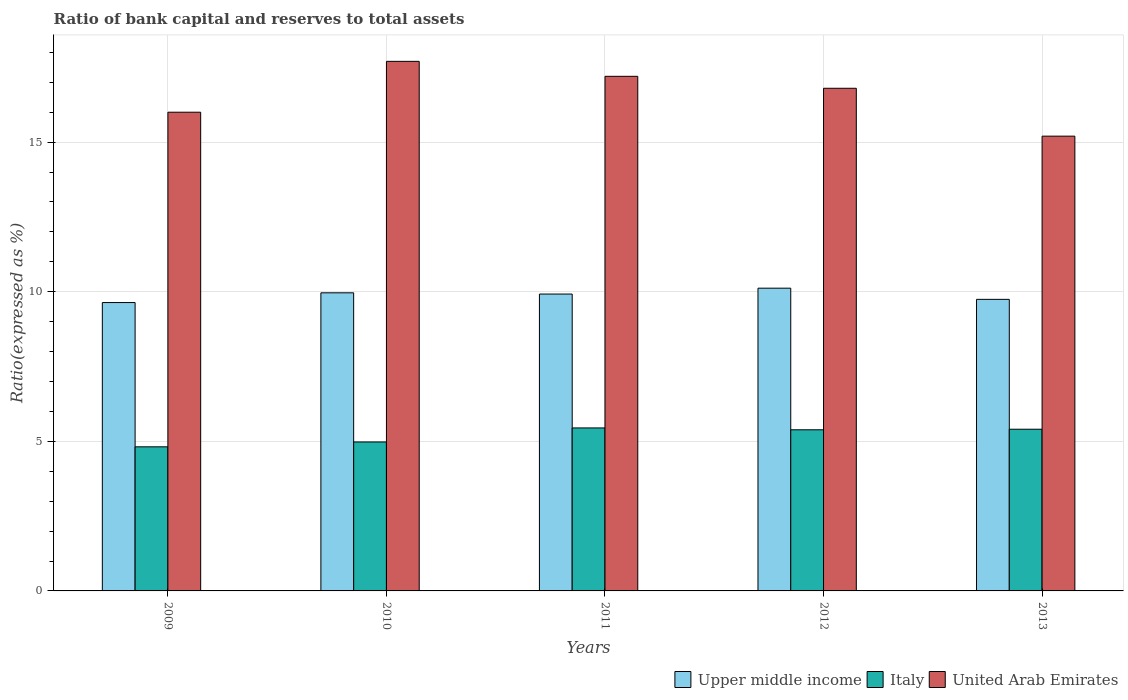How many different coloured bars are there?
Give a very brief answer. 3. How many bars are there on the 4th tick from the left?
Keep it short and to the point. 3. How many bars are there on the 4th tick from the right?
Your answer should be compact. 3. What is the ratio of bank capital and reserves to total assets in Italy in 2011?
Provide a succinct answer. 5.45. Across all years, what is the maximum ratio of bank capital and reserves to total assets in Italy?
Ensure brevity in your answer.  5.45. What is the total ratio of bank capital and reserves to total assets in Upper middle income in the graph?
Provide a succinct answer. 49.39. What is the difference between the ratio of bank capital and reserves to total assets in United Arab Emirates in 2009 and that in 2011?
Give a very brief answer. -1.2. What is the difference between the ratio of bank capital and reserves to total assets in United Arab Emirates in 2009 and the ratio of bank capital and reserves to total assets in Upper middle income in 2012?
Your answer should be very brief. 5.88. What is the average ratio of bank capital and reserves to total assets in United Arab Emirates per year?
Your response must be concise. 16.58. In the year 2011, what is the difference between the ratio of bank capital and reserves to total assets in Italy and ratio of bank capital and reserves to total assets in Upper middle income?
Keep it short and to the point. -4.47. What is the ratio of the ratio of bank capital and reserves to total assets in Upper middle income in 2009 to that in 2011?
Offer a very short reply. 0.97. Is the ratio of bank capital and reserves to total assets in United Arab Emirates in 2010 less than that in 2012?
Provide a short and direct response. No. What is the difference between the highest and the second highest ratio of bank capital and reserves to total assets in United Arab Emirates?
Give a very brief answer. 0.5. What is the difference between the highest and the lowest ratio of bank capital and reserves to total assets in Italy?
Make the answer very short. 0.63. In how many years, is the ratio of bank capital and reserves to total assets in United Arab Emirates greater than the average ratio of bank capital and reserves to total assets in United Arab Emirates taken over all years?
Ensure brevity in your answer.  3. Is the sum of the ratio of bank capital and reserves to total assets in United Arab Emirates in 2009 and 2010 greater than the maximum ratio of bank capital and reserves to total assets in Upper middle income across all years?
Make the answer very short. Yes. What does the 2nd bar from the left in 2012 represents?
Provide a short and direct response. Italy. What does the 1st bar from the right in 2011 represents?
Give a very brief answer. United Arab Emirates. Is it the case that in every year, the sum of the ratio of bank capital and reserves to total assets in Upper middle income and ratio of bank capital and reserves to total assets in Italy is greater than the ratio of bank capital and reserves to total assets in United Arab Emirates?
Keep it short and to the point. No. What is the difference between two consecutive major ticks on the Y-axis?
Your answer should be very brief. 5. Are the values on the major ticks of Y-axis written in scientific E-notation?
Give a very brief answer. No. Does the graph contain any zero values?
Give a very brief answer. No. Does the graph contain grids?
Your answer should be very brief. Yes. What is the title of the graph?
Provide a short and direct response. Ratio of bank capital and reserves to total assets. What is the label or title of the X-axis?
Keep it short and to the point. Years. What is the label or title of the Y-axis?
Make the answer very short. Ratio(expressed as %). What is the Ratio(expressed as %) of Upper middle income in 2009?
Your answer should be compact. 9.64. What is the Ratio(expressed as %) in Italy in 2009?
Ensure brevity in your answer.  4.82. What is the Ratio(expressed as %) in United Arab Emirates in 2009?
Make the answer very short. 16. What is the Ratio(expressed as %) of Upper middle income in 2010?
Make the answer very short. 9.96. What is the Ratio(expressed as %) of Italy in 2010?
Ensure brevity in your answer.  4.98. What is the Ratio(expressed as %) in United Arab Emirates in 2010?
Give a very brief answer. 17.7. What is the Ratio(expressed as %) of Upper middle income in 2011?
Keep it short and to the point. 9.92. What is the Ratio(expressed as %) in Italy in 2011?
Provide a succinct answer. 5.45. What is the Ratio(expressed as %) of Upper middle income in 2012?
Offer a very short reply. 10.12. What is the Ratio(expressed as %) in Italy in 2012?
Offer a terse response. 5.39. What is the Ratio(expressed as %) of United Arab Emirates in 2012?
Offer a terse response. 16.8. What is the Ratio(expressed as %) of Upper middle income in 2013?
Your answer should be very brief. 9.75. What is the Ratio(expressed as %) of Italy in 2013?
Your answer should be compact. 5.4. Across all years, what is the maximum Ratio(expressed as %) in Upper middle income?
Provide a succinct answer. 10.12. Across all years, what is the maximum Ratio(expressed as %) of Italy?
Provide a succinct answer. 5.45. Across all years, what is the minimum Ratio(expressed as %) of Upper middle income?
Your answer should be compact. 9.64. Across all years, what is the minimum Ratio(expressed as %) in Italy?
Make the answer very short. 4.82. Across all years, what is the minimum Ratio(expressed as %) of United Arab Emirates?
Your answer should be compact. 15.2. What is the total Ratio(expressed as %) of Upper middle income in the graph?
Your answer should be very brief. 49.39. What is the total Ratio(expressed as %) in Italy in the graph?
Provide a short and direct response. 26.03. What is the total Ratio(expressed as %) of United Arab Emirates in the graph?
Your response must be concise. 82.9. What is the difference between the Ratio(expressed as %) of Upper middle income in 2009 and that in 2010?
Keep it short and to the point. -0.33. What is the difference between the Ratio(expressed as %) in Italy in 2009 and that in 2010?
Offer a terse response. -0.16. What is the difference between the Ratio(expressed as %) in Upper middle income in 2009 and that in 2011?
Offer a very short reply. -0.28. What is the difference between the Ratio(expressed as %) of Italy in 2009 and that in 2011?
Your answer should be very brief. -0.63. What is the difference between the Ratio(expressed as %) in United Arab Emirates in 2009 and that in 2011?
Make the answer very short. -1.2. What is the difference between the Ratio(expressed as %) in Upper middle income in 2009 and that in 2012?
Provide a succinct answer. -0.48. What is the difference between the Ratio(expressed as %) in Italy in 2009 and that in 2012?
Give a very brief answer. -0.57. What is the difference between the Ratio(expressed as %) of Upper middle income in 2009 and that in 2013?
Provide a succinct answer. -0.11. What is the difference between the Ratio(expressed as %) of Italy in 2009 and that in 2013?
Keep it short and to the point. -0.59. What is the difference between the Ratio(expressed as %) in United Arab Emirates in 2009 and that in 2013?
Your answer should be very brief. 0.8. What is the difference between the Ratio(expressed as %) of Upper middle income in 2010 and that in 2011?
Your response must be concise. 0.04. What is the difference between the Ratio(expressed as %) in Italy in 2010 and that in 2011?
Offer a very short reply. -0.47. What is the difference between the Ratio(expressed as %) in United Arab Emirates in 2010 and that in 2011?
Give a very brief answer. 0.5. What is the difference between the Ratio(expressed as %) of Upper middle income in 2010 and that in 2012?
Your response must be concise. -0.16. What is the difference between the Ratio(expressed as %) in Italy in 2010 and that in 2012?
Your answer should be very brief. -0.41. What is the difference between the Ratio(expressed as %) of United Arab Emirates in 2010 and that in 2012?
Provide a short and direct response. 0.9. What is the difference between the Ratio(expressed as %) in Upper middle income in 2010 and that in 2013?
Your answer should be very brief. 0.22. What is the difference between the Ratio(expressed as %) in Italy in 2010 and that in 2013?
Your answer should be compact. -0.43. What is the difference between the Ratio(expressed as %) of United Arab Emirates in 2010 and that in 2013?
Make the answer very short. 2.5. What is the difference between the Ratio(expressed as %) in Upper middle income in 2011 and that in 2012?
Keep it short and to the point. -0.2. What is the difference between the Ratio(expressed as %) in Italy in 2011 and that in 2012?
Give a very brief answer. 0.06. What is the difference between the Ratio(expressed as %) of United Arab Emirates in 2011 and that in 2012?
Your answer should be compact. 0.4. What is the difference between the Ratio(expressed as %) of Upper middle income in 2011 and that in 2013?
Give a very brief answer. 0.18. What is the difference between the Ratio(expressed as %) of Italy in 2011 and that in 2013?
Offer a terse response. 0.04. What is the difference between the Ratio(expressed as %) in Upper middle income in 2012 and that in 2013?
Keep it short and to the point. 0.37. What is the difference between the Ratio(expressed as %) in Italy in 2012 and that in 2013?
Give a very brief answer. -0.02. What is the difference between the Ratio(expressed as %) in Upper middle income in 2009 and the Ratio(expressed as %) in Italy in 2010?
Give a very brief answer. 4.66. What is the difference between the Ratio(expressed as %) in Upper middle income in 2009 and the Ratio(expressed as %) in United Arab Emirates in 2010?
Your answer should be very brief. -8.06. What is the difference between the Ratio(expressed as %) in Italy in 2009 and the Ratio(expressed as %) in United Arab Emirates in 2010?
Keep it short and to the point. -12.88. What is the difference between the Ratio(expressed as %) of Upper middle income in 2009 and the Ratio(expressed as %) of Italy in 2011?
Offer a terse response. 4.19. What is the difference between the Ratio(expressed as %) in Upper middle income in 2009 and the Ratio(expressed as %) in United Arab Emirates in 2011?
Provide a short and direct response. -7.56. What is the difference between the Ratio(expressed as %) in Italy in 2009 and the Ratio(expressed as %) in United Arab Emirates in 2011?
Offer a very short reply. -12.38. What is the difference between the Ratio(expressed as %) in Upper middle income in 2009 and the Ratio(expressed as %) in Italy in 2012?
Make the answer very short. 4.25. What is the difference between the Ratio(expressed as %) in Upper middle income in 2009 and the Ratio(expressed as %) in United Arab Emirates in 2012?
Offer a terse response. -7.16. What is the difference between the Ratio(expressed as %) of Italy in 2009 and the Ratio(expressed as %) of United Arab Emirates in 2012?
Offer a terse response. -11.98. What is the difference between the Ratio(expressed as %) in Upper middle income in 2009 and the Ratio(expressed as %) in Italy in 2013?
Offer a terse response. 4.23. What is the difference between the Ratio(expressed as %) of Upper middle income in 2009 and the Ratio(expressed as %) of United Arab Emirates in 2013?
Your answer should be very brief. -5.56. What is the difference between the Ratio(expressed as %) of Italy in 2009 and the Ratio(expressed as %) of United Arab Emirates in 2013?
Your answer should be compact. -10.38. What is the difference between the Ratio(expressed as %) of Upper middle income in 2010 and the Ratio(expressed as %) of Italy in 2011?
Ensure brevity in your answer.  4.52. What is the difference between the Ratio(expressed as %) in Upper middle income in 2010 and the Ratio(expressed as %) in United Arab Emirates in 2011?
Offer a very short reply. -7.24. What is the difference between the Ratio(expressed as %) in Italy in 2010 and the Ratio(expressed as %) in United Arab Emirates in 2011?
Offer a very short reply. -12.22. What is the difference between the Ratio(expressed as %) of Upper middle income in 2010 and the Ratio(expressed as %) of Italy in 2012?
Your answer should be very brief. 4.58. What is the difference between the Ratio(expressed as %) in Upper middle income in 2010 and the Ratio(expressed as %) in United Arab Emirates in 2012?
Make the answer very short. -6.84. What is the difference between the Ratio(expressed as %) in Italy in 2010 and the Ratio(expressed as %) in United Arab Emirates in 2012?
Offer a terse response. -11.82. What is the difference between the Ratio(expressed as %) of Upper middle income in 2010 and the Ratio(expressed as %) of Italy in 2013?
Provide a succinct answer. 4.56. What is the difference between the Ratio(expressed as %) in Upper middle income in 2010 and the Ratio(expressed as %) in United Arab Emirates in 2013?
Keep it short and to the point. -5.24. What is the difference between the Ratio(expressed as %) in Italy in 2010 and the Ratio(expressed as %) in United Arab Emirates in 2013?
Offer a very short reply. -10.22. What is the difference between the Ratio(expressed as %) of Upper middle income in 2011 and the Ratio(expressed as %) of Italy in 2012?
Make the answer very short. 4.54. What is the difference between the Ratio(expressed as %) in Upper middle income in 2011 and the Ratio(expressed as %) in United Arab Emirates in 2012?
Provide a short and direct response. -6.88. What is the difference between the Ratio(expressed as %) in Italy in 2011 and the Ratio(expressed as %) in United Arab Emirates in 2012?
Make the answer very short. -11.35. What is the difference between the Ratio(expressed as %) in Upper middle income in 2011 and the Ratio(expressed as %) in Italy in 2013?
Your response must be concise. 4.52. What is the difference between the Ratio(expressed as %) in Upper middle income in 2011 and the Ratio(expressed as %) in United Arab Emirates in 2013?
Provide a succinct answer. -5.28. What is the difference between the Ratio(expressed as %) of Italy in 2011 and the Ratio(expressed as %) of United Arab Emirates in 2013?
Your answer should be very brief. -9.75. What is the difference between the Ratio(expressed as %) of Upper middle income in 2012 and the Ratio(expressed as %) of Italy in 2013?
Make the answer very short. 4.71. What is the difference between the Ratio(expressed as %) of Upper middle income in 2012 and the Ratio(expressed as %) of United Arab Emirates in 2013?
Give a very brief answer. -5.08. What is the difference between the Ratio(expressed as %) of Italy in 2012 and the Ratio(expressed as %) of United Arab Emirates in 2013?
Your answer should be compact. -9.81. What is the average Ratio(expressed as %) in Upper middle income per year?
Offer a very short reply. 9.88. What is the average Ratio(expressed as %) of Italy per year?
Your response must be concise. 5.21. What is the average Ratio(expressed as %) in United Arab Emirates per year?
Keep it short and to the point. 16.58. In the year 2009, what is the difference between the Ratio(expressed as %) in Upper middle income and Ratio(expressed as %) in Italy?
Provide a succinct answer. 4.82. In the year 2009, what is the difference between the Ratio(expressed as %) of Upper middle income and Ratio(expressed as %) of United Arab Emirates?
Provide a short and direct response. -6.36. In the year 2009, what is the difference between the Ratio(expressed as %) in Italy and Ratio(expressed as %) in United Arab Emirates?
Provide a succinct answer. -11.18. In the year 2010, what is the difference between the Ratio(expressed as %) in Upper middle income and Ratio(expressed as %) in Italy?
Keep it short and to the point. 4.98. In the year 2010, what is the difference between the Ratio(expressed as %) of Upper middle income and Ratio(expressed as %) of United Arab Emirates?
Your answer should be compact. -7.74. In the year 2010, what is the difference between the Ratio(expressed as %) in Italy and Ratio(expressed as %) in United Arab Emirates?
Your response must be concise. -12.72. In the year 2011, what is the difference between the Ratio(expressed as %) in Upper middle income and Ratio(expressed as %) in Italy?
Keep it short and to the point. 4.47. In the year 2011, what is the difference between the Ratio(expressed as %) of Upper middle income and Ratio(expressed as %) of United Arab Emirates?
Offer a terse response. -7.28. In the year 2011, what is the difference between the Ratio(expressed as %) of Italy and Ratio(expressed as %) of United Arab Emirates?
Give a very brief answer. -11.75. In the year 2012, what is the difference between the Ratio(expressed as %) in Upper middle income and Ratio(expressed as %) in Italy?
Your answer should be compact. 4.73. In the year 2012, what is the difference between the Ratio(expressed as %) of Upper middle income and Ratio(expressed as %) of United Arab Emirates?
Offer a terse response. -6.68. In the year 2012, what is the difference between the Ratio(expressed as %) in Italy and Ratio(expressed as %) in United Arab Emirates?
Your answer should be very brief. -11.41. In the year 2013, what is the difference between the Ratio(expressed as %) of Upper middle income and Ratio(expressed as %) of Italy?
Provide a short and direct response. 4.34. In the year 2013, what is the difference between the Ratio(expressed as %) in Upper middle income and Ratio(expressed as %) in United Arab Emirates?
Make the answer very short. -5.45. In the year 2013, what is the difference between the Ratio(expressed as %) in Italy and Ratio(expressed as %) in United Arab Emirates?
Give a very brief answer. -9.8. What is the ratio of the Ratio(expressed as %) of Upper middle income in 2009 to that in 2010?
Your answer should be compact. 0.97. What is the ratio of the Ratio(expressed as %) of Italy in 2009 to that in 2010?
Keep it short and to the point. 0.97. What is the ratio of the Ratio(expressed as %) in United Arab Emirates in 2009 to that in 2010?
Your answer should be very brief. 0.9. What is the ratio of the Ratio(expressed as %) of Upper middle income in 2009 to that in 2011?
Offer a very short reply. 0.97. What is the ratio of the Ratio(expressed as %) in Italy in 2009 to that in 2011?
Offer a terse response. 0.88. What is the ratio of the Ratio(expressed as %) in United Arab Emirates in 2009 to that in 2011?
Provide a succinct answer. 0.93. What is the ratio of the Ratio(expressed as %) in Upper middle income in 2009 to that in 2012?
Give a very brief answer. 0.95. What is the ratio of the Ratio(expressed as %) in Italy in 2009 to that in 2012?
Provide a succinct answer. 0.89. What is the ratio of the Ratio(expressed as %) of Italy in 2009 to that in 2013?
Provide a short and direct response. 0.89. What is the ratio of the Ratio(expressed as %) in United Arab Emirates in 2009 to that in 2013?
Offer a very short reply. 1.05. What is the ratio of the Ratio(expressed as %) in Italy in 2010 to that in 2011?
Your answer should be very brief. 0.91. What is the ratio of the Ratio(expressed as %) in United Arab Emirates in 2010 to that in 2011?
Your answer should be very brief. 1.03. What is the ratio of the Ratio(expressed as %) of Upper middle income in 2010 to that in 2012?
Provide a succinct answer. 0.98. What is the ratio of the Ratio(expressed as %) in Italy in 2010 to that in 2012?
Your response must be concise. 0.92. What is the ratio of the Ratio(expressed as %) of United Arab Emirates in 2010 to that in 2012?
Ensure brevity in your answer.  1.05. What is the ratio of the Ratio(expressed as %) of Upper middle income in 2010 to that in 2013?
Your answer should be compact. 1.02. What is the ratio of the Ratio(expressed as %) of Italy in 2010 to that in 2013?
Offer a very short reply. 0.92. What is the ratio of the Ratio(expressed as %) in United Arab Emirates in 2010 to that in 2013?
Keep it short and to the point. 1.16. What is the ratio of the Ratio(expressed as %) in Upper middle income in 2011 to that in 2012?
Your response must be concise. 0.98. What is the ratio of the Ratio(expressed as %) of Italy in 2011 to that in 2012?
Your response must be concise. 1.01. What is the ratio of the Ratio(expressed as %) of United Arab Emirates in 2011 to that in 2012?
Your answer should be compact. 1.02. What is the ratio of the Ratio(expressed as %) of Upper middle income in 2011 to that in 2013?
Ensure brevity in your answer.  1.02. What is the ratio of the Ratio(expressed as %) in Italy in 2011 to that in 2013?
Provide a short and direct response. 1.01. What is the ratio of the Ratio(expressed as %) in United Arab Emirates in 2011 to that in 2013?
Offer a very short reply. 1.13. What is the ratio of the Ratio(expressed as %) in Upper middle income in 2012 to that in 2013?
Offer a terse response. 1.04. What is the ratio of the Ratio(expressed as %) of Italy in 2012 to that in 2013?
Your answer should be compact. 1. What is the ratio of the Ratio(expressed as %) of United Arab Emirates in 2012 to that in 2013?
Your response must be concise. 1.11. What is the difference between the highest and the second highest Ratio(expressed as %) in Upper middle income?
Your answer should be very brief. 0.16. What is the difference between the highest and the second highest Ratio(expressed as %) in Italy?
Provide a short and direct response. 0.04. What is the difference between the highest and the lowest Ratio(expressed as %) of Upper middle income?
Give a very brief answer. 0.48. What is the difference between the highest and the lowest Ratio(expressed as %) of Italy?
Offer a very short reply. 0.63. 